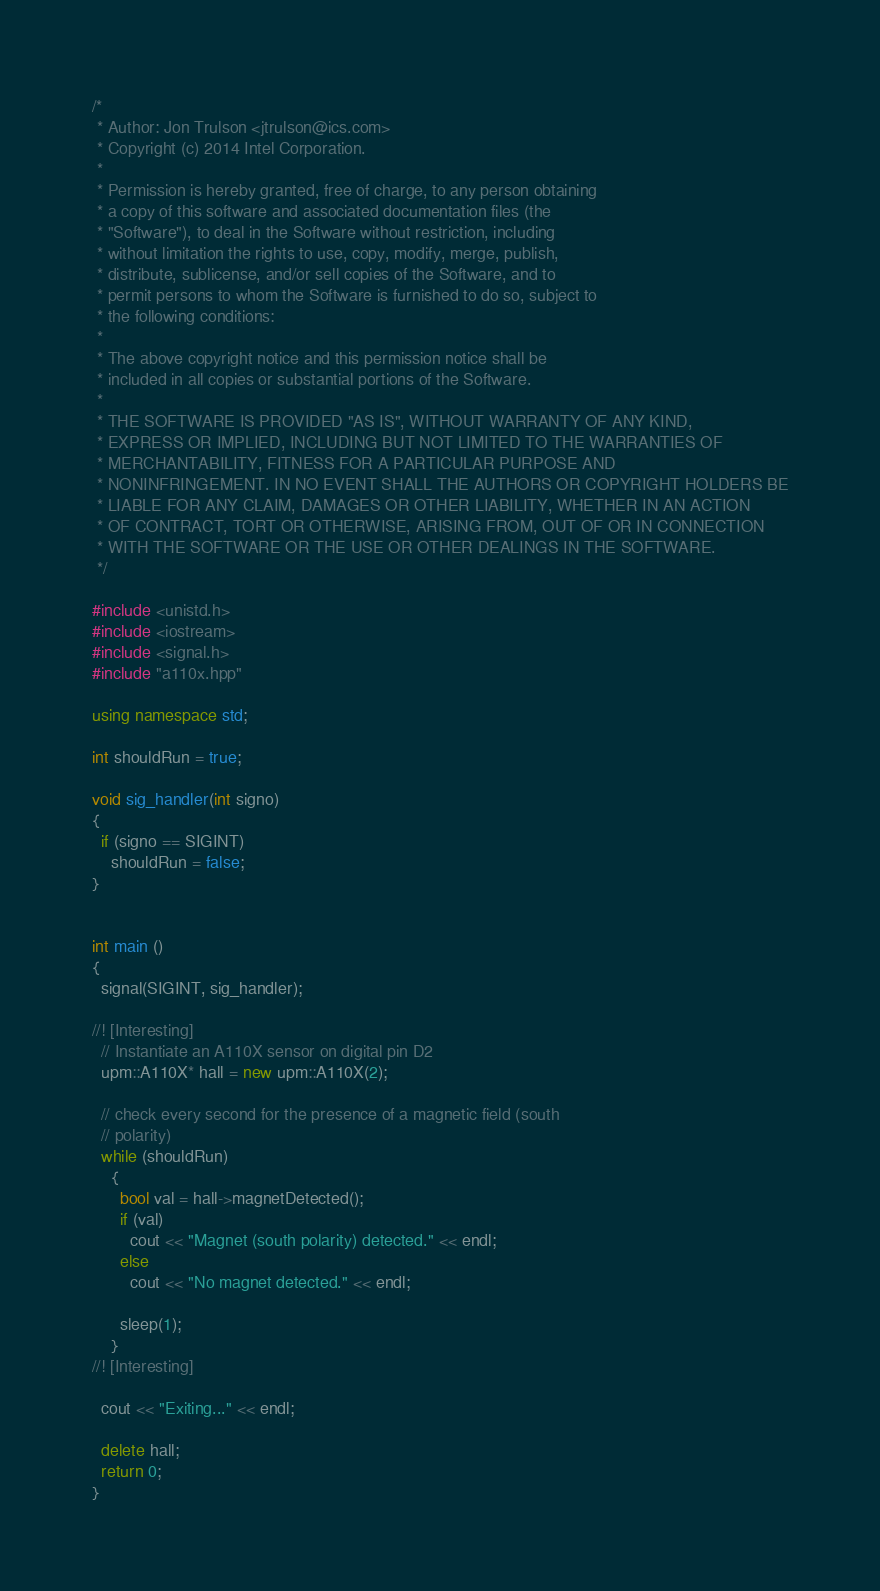<code> <loc_0><loc_0><loc_500><loc_500><_C++_>/*
 * Author: Jon Trulson <jtrulson@ics.com>
 * Copyright (c) 2014 Intel Corporation.
 *
 * Permission is hereby granted, free of charge, to any person obtaining
 * a copy of this software and associated documentation files (the
 * "Software"), to deal in the Software without restriction, including
 * without limitation the rights to use, copy, modify, merge, publish,
 * distribute, sublicense, and/or sell copies of the Software, and to
 * permit persons to whom the Software is furnished to do so, subject to
 * the following conditions:
 *
 * The above copyright notice and this permission notice shall be
 * included in all copies or substantial portions of the Software.
 *
 * THE SOFTWARE IS PROVIDED "AS IS", WITHOUT WARRANTY OF ANY KIND,
 * EXPRESS OR IMPLIED, INCLUDING BUT NOT LIMITED TO THE WARRANTIES OF
 * MERCHANTABILITY, FITNESS FOR A PARTICULAR PURPOSE AND
 * NONINFRINGEMENT. IN NO EVENT SHALL THE AUTHORS OR COPYRIGHT HOLDERS BE
 * LIABLE FOR ANY CLAIM, DAMAGES OR OTHER LIABILITY, WHETHER IN AN ACTION
 * OF CONTRACT, TORT OR OTHERWISE, ARISING FROM, OUT OF OR IN CONNECTION
 * WITH THE SOFTWARE OR THE USE OR OTHER DEALINGS IN THE SOFTWARE.
 */

#include <unistd.h>
#include <iostream>
#include <signal.h>
#include "a110x.hpp"

using namespace std;

int shouldRun = true;

void sig_handler(int signo)
{
  if (signo == SIGINT)
    shouldRun = false;
}


int main ()
{
  signal(SIGINT, sig_handler);

//! [Interesting]
  // Instantiate an A110X sensor on digital pin D2
  upm::A110X* hall = new upm::A110X(2);
  
  // check every second for the presence of a magnetic field (south
  // polarity)
  while (shouldRun)
    {
      bool val = hall->magnetDetected();
      if (val)
        cout << "Magnet (south polarity) detected." << endl;
      else
        cout << "No magnet detected." << endl;

      sleep(1);
    }
//! [Interesting]

  cout << "Exiting..." << endl;

  delete hall;
  return 0;
}
</code> 